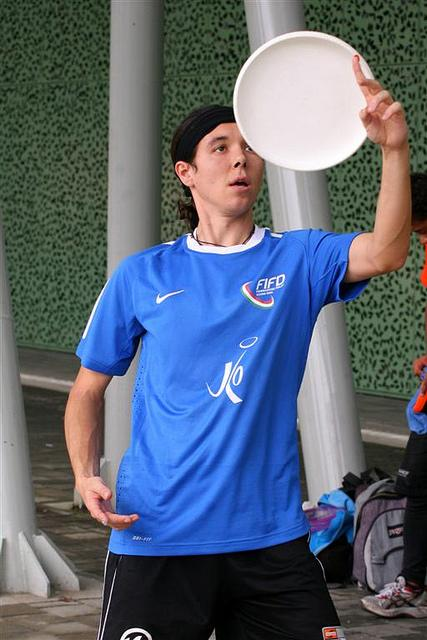What is he doing with the frisbee? tricks 